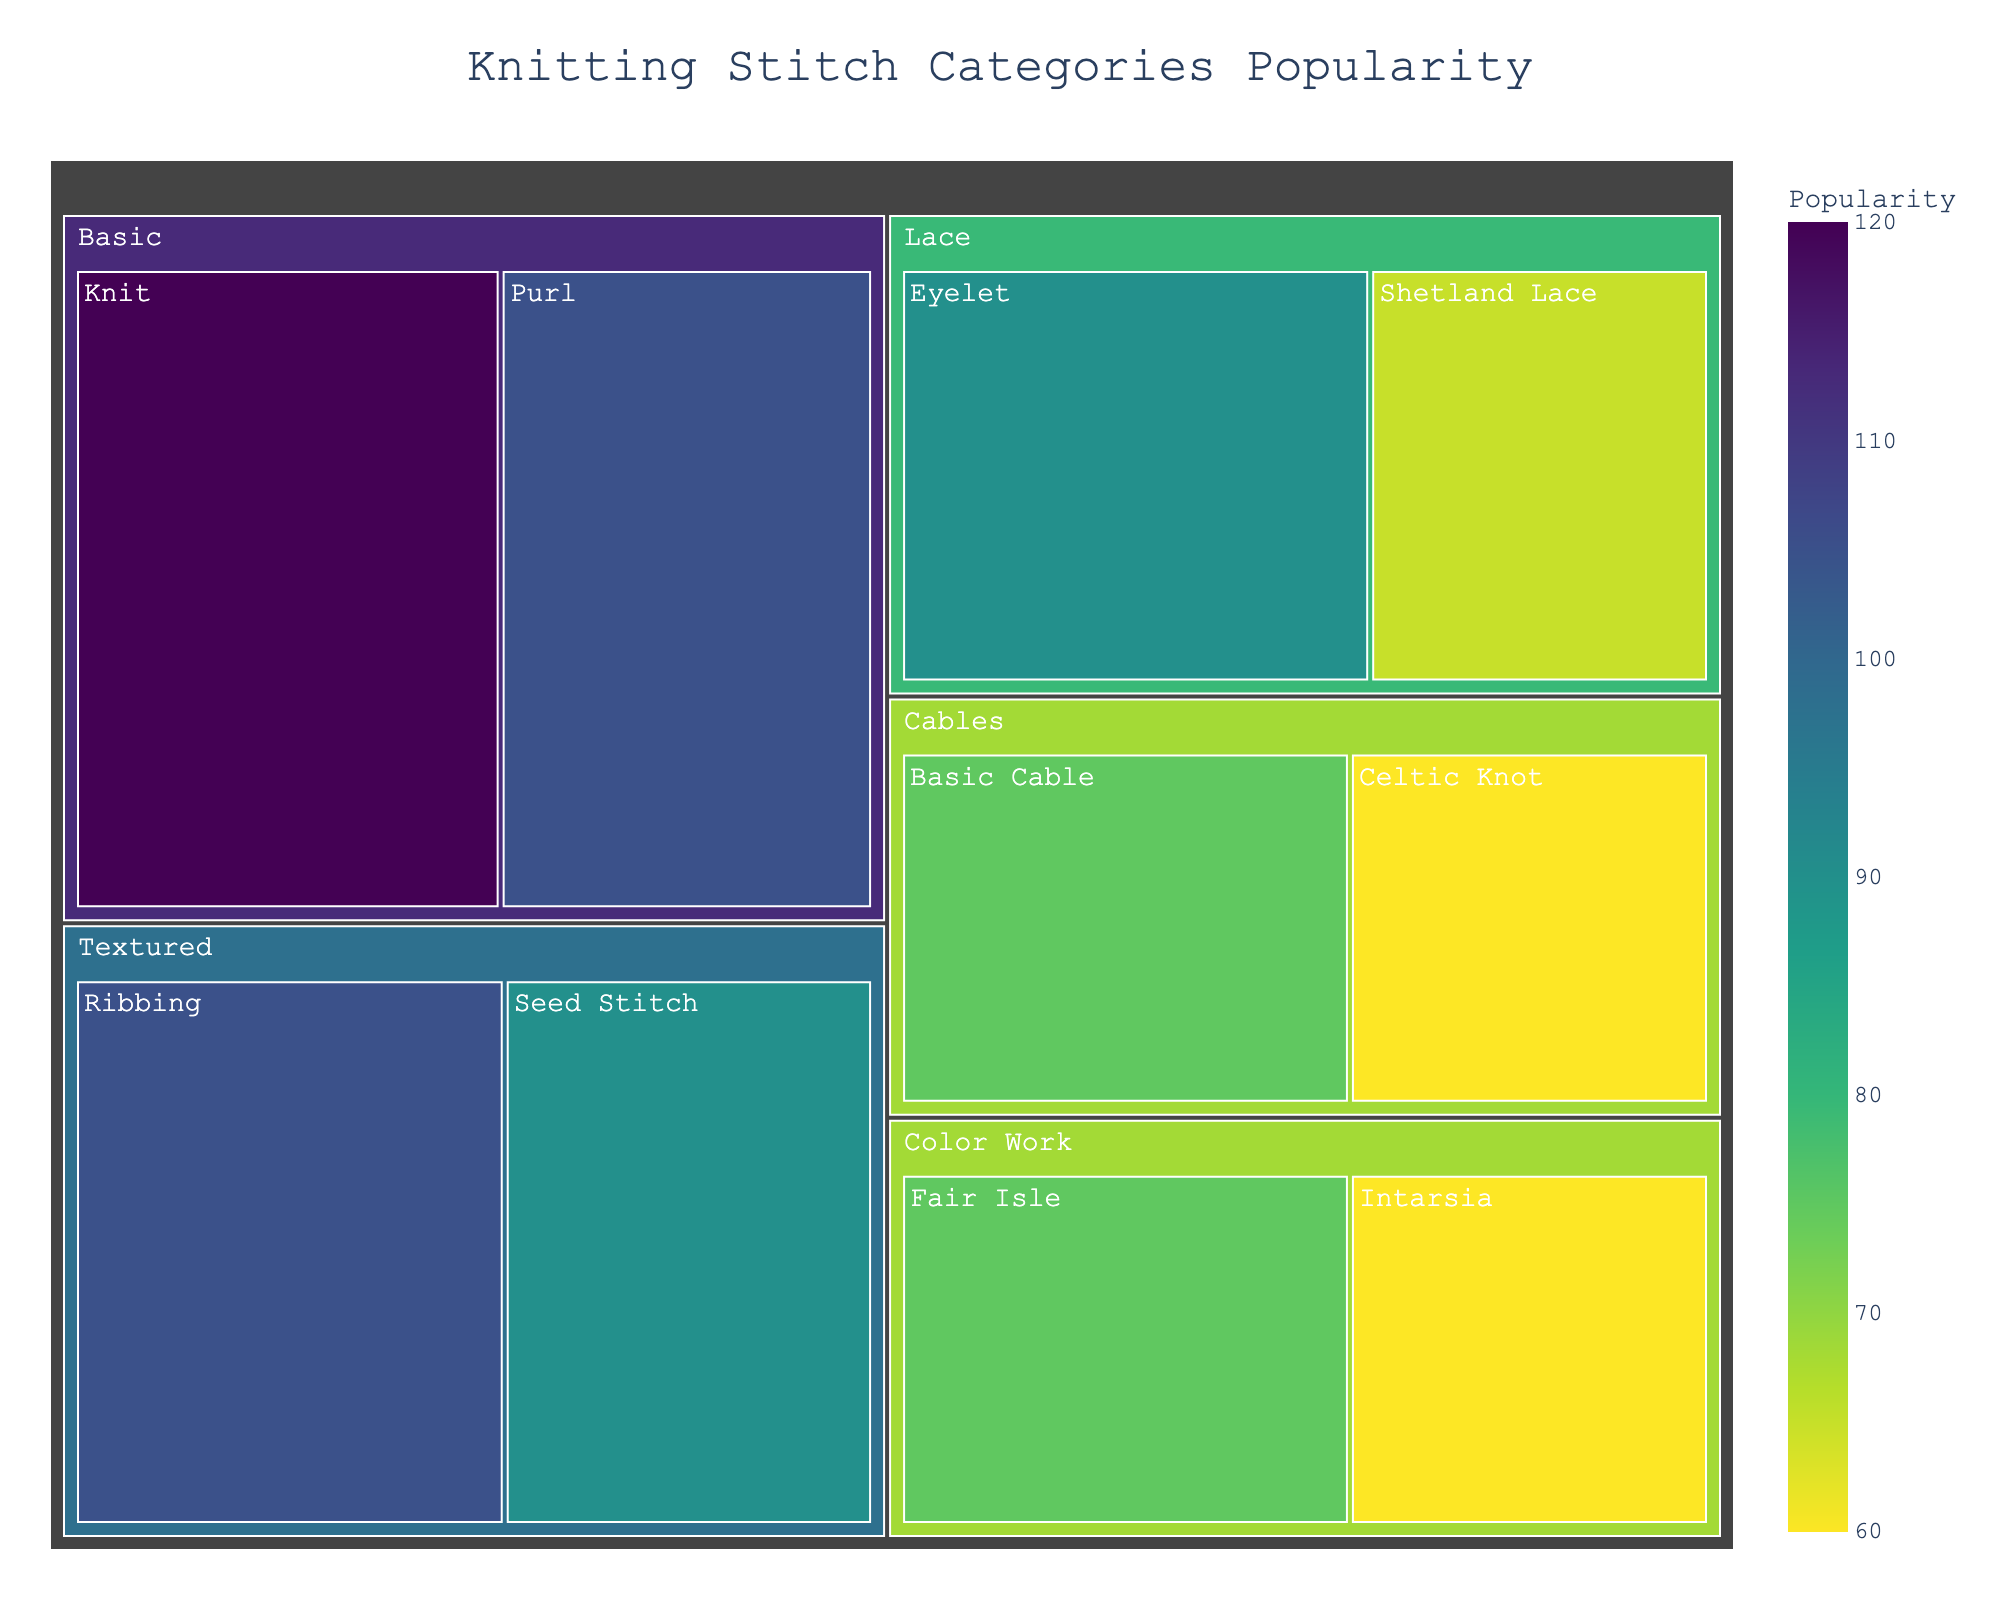What is the title of the figure? The title is typically found at the top of the figure, and it provides the main description of the figure's content.
Answer: Knitting Stitch Categories Popularity Which category has the highest overall popularity? To determine the category with the highest overall popularity, look for the largest section in the figure.
Answer: Basic How many subcategories are there in total? Count all the distinct subcategories within different categories in the figure.
Answer: 10 What is the combined popularity of Knit and Purl stitches among all age groups? Add the popularity values of Knit and Purl stitches across all age groups. 35+40+45+30+35+40 = 225
Answer: 225 Which age group shows the highest popularity for Shetland Lace? Identify the age group bar for Shetland Lace and compare their popularity values.
Answer: 51+ Among Cables, which subcategory is more popular in the age group 31-50? Compare the popularity values of Basic Cable and Celtic Knot in the age group 31-50.
Answer: Basic Cable What is the total popularity of Textured stitches across all age groups? Sum the popularity values of all subcategories under Textured stitches across all age groups. 25+30+35+30+35+40 = 195
Answer: 195 Which age group has the lowest interest in Fair Isle? Compare the popularity for Fair Isle among all age groups to find the minimum value.
Answer: 18-30 Is the popularity of Intarsia higher in the age group 51+ than in 18-30? Compare the popularity values of Intarsia in 51+ and 18-30 age groups. 25 > 15
Answer: Yes Which category has the most balanced popularity across its subcategories? Evaluate the popularity values in each category to find the one with the least variation among its subcategories. Both Knit and Purl in the Basic category show similar values.
Answer: Basic 